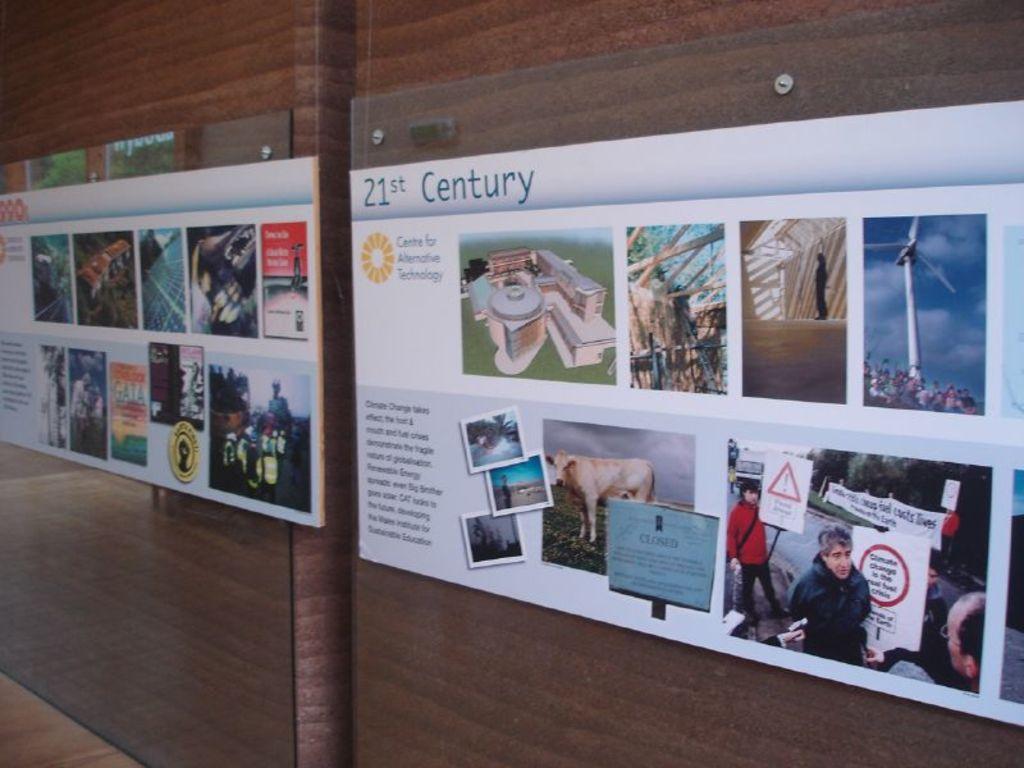What century is cited in the display?
Ensure brevity in your answer.  21st. What decade is covered in the left panel?
Offer a terse response. 21st. 